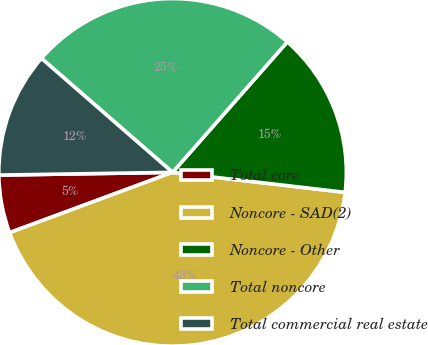Convert chart to OTSL. <chart><loc_0><loc_0><loc_500><loc_500><pie_chart><fcel>Total core<fcel>Noncore - SAD(2)<fcel>Noncore - Other<fcel>Total noncore<fcel>Total commercial real estate<nl><fcel>5.39%<fcel>42.52%<fcel>15.35%<fcel>25.09%<fcel>11.64%<nl></chart> 